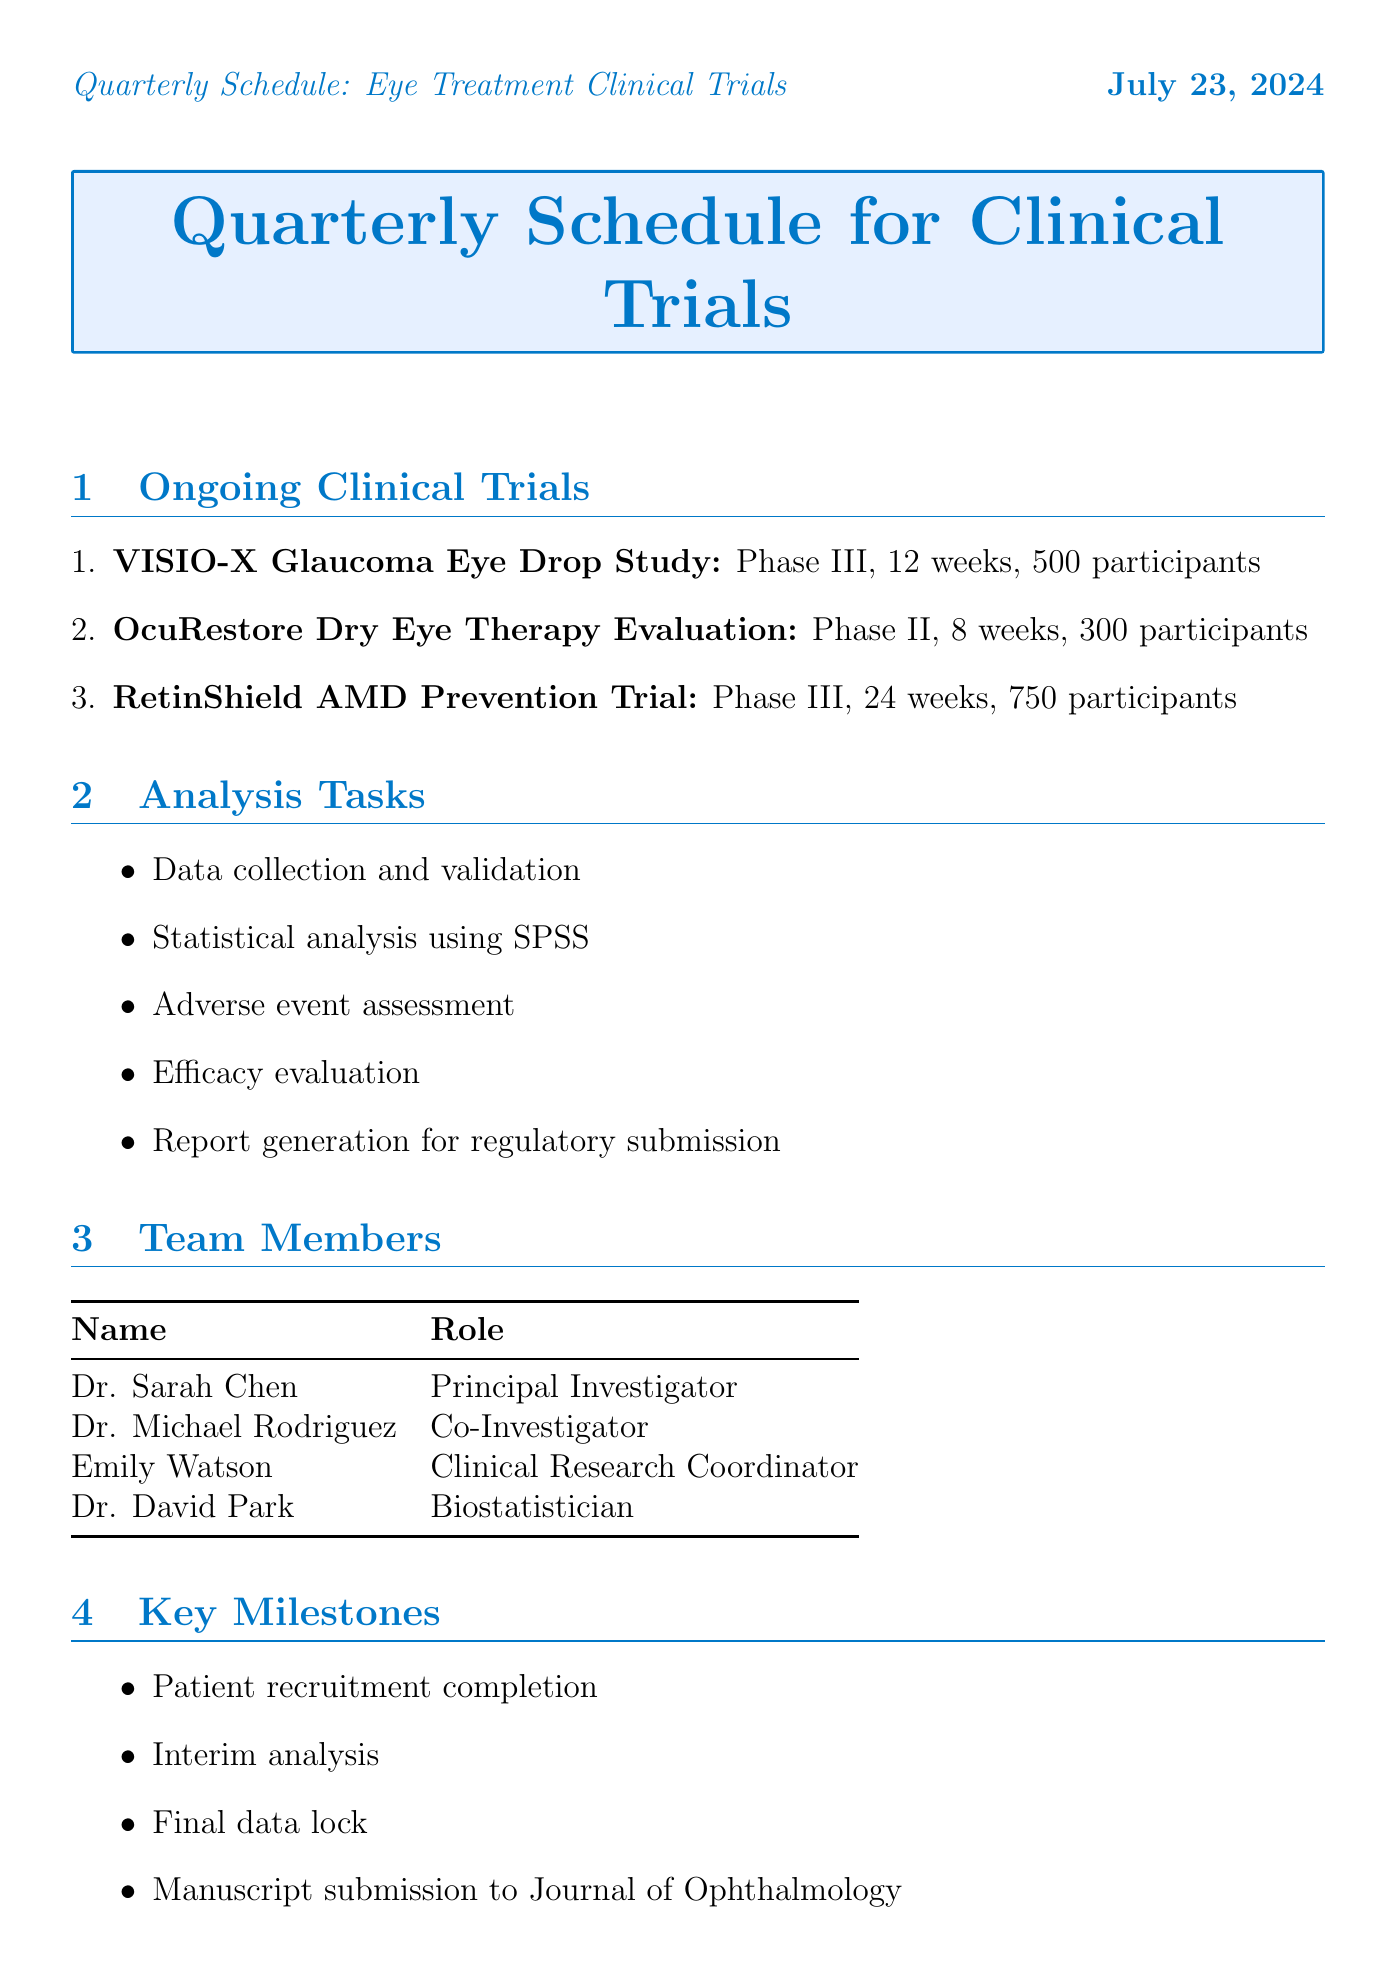What is the name of the Phase III study? The document mentions "VISIO-X Glaucoma Eye Drop Study" and "RetinShield AMD Prevention Trial" as Phase III studies, but it asks specifically for one.
Answer: VISIO-X Glaucoma Eye Drop Study How many participants are involved in the OcuRestore study? OcuRestore Dry Eye Therapy Evaluation mentions a total of 300 participants.
Answer: 300 participants What is the primary outcome of the RetinShield trial? The primary outcome for the RetinShield AMD Prevention Trial is mentioned as "Progression of geographic atrophy".
Answer: Progression of geographic atrophy Who is the Principal Investigator? "Dr. Sarah Chen" is listed as the Principal Investigator in the team members section.
Answer: Dr. Sarah Chen What is the budget percentage allocated to staff salaries? The budget allocation table specifies that 40% is designated for staff salaries.
Answer: 40% What analysis tool is used in the clinical trials? The document states "Statistical analysis using SPSS" as part of the analysis tasks.
Answer: SPSS What is the follow-up time frame for week 12? The document specifies that the week 12 follow-up is "if applicable."
Answer: if applicable How many key milestones are listed in the document? The key milestones section contains four items listed.
Answer: 4 